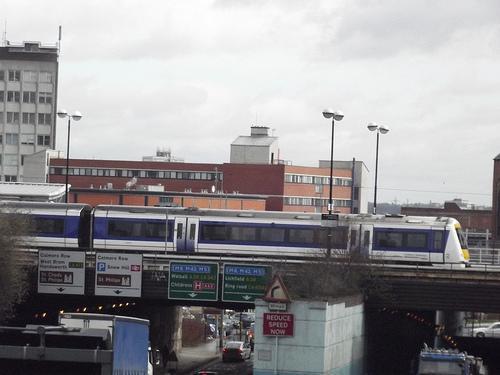How many trains are shown?
Give a very brief answer. 1. 